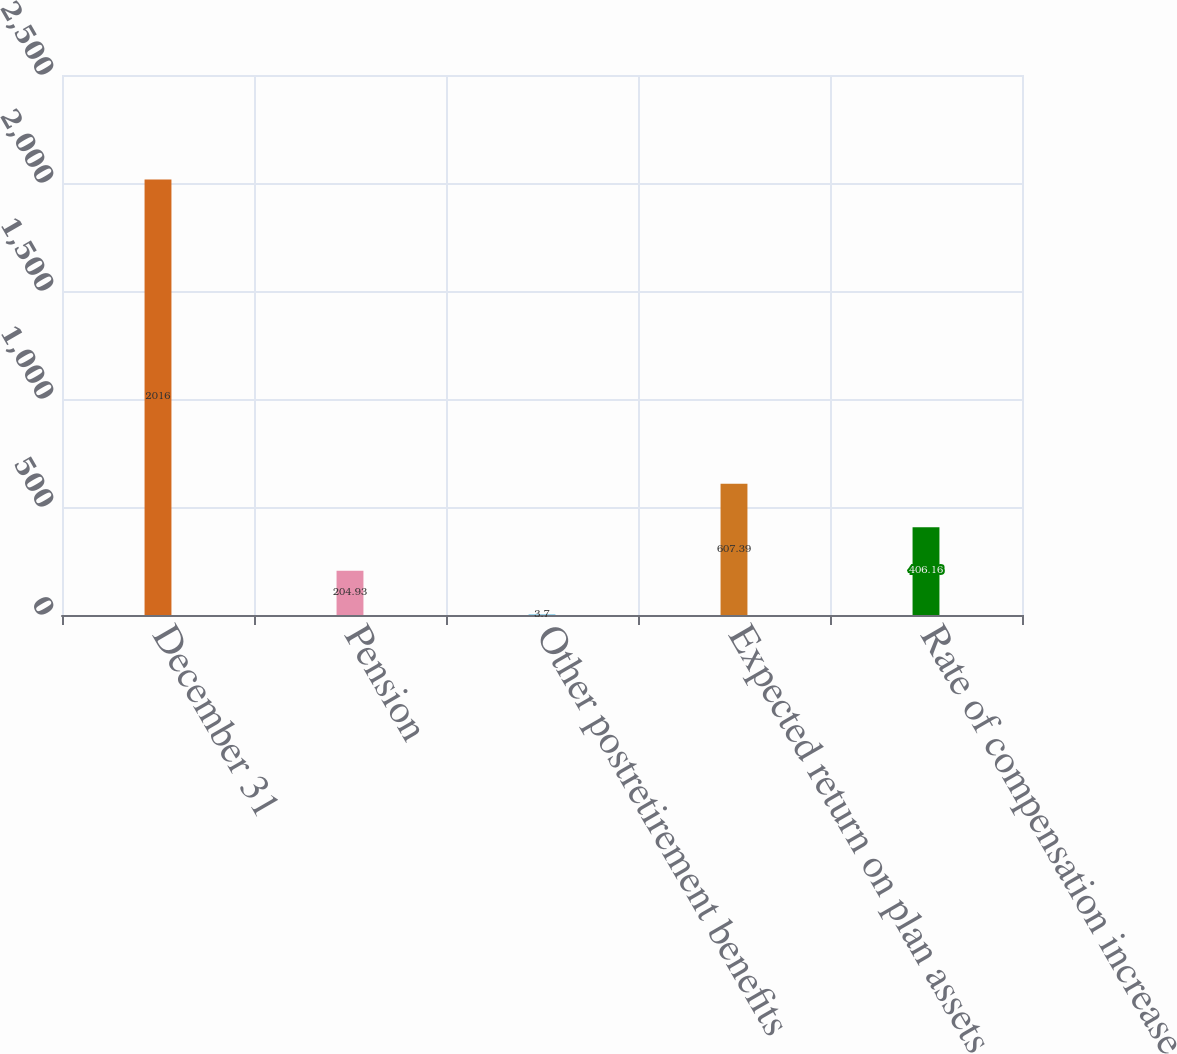Convert chart. <chart><loc_0><loc_0><loc_500><loc_500><bar_chart><fcel>December 31<fcel>Pension<fcel>Other postretirement benefits<fcel>Expected return on plan assets<fcel>Rate of compensation increase<nl><fcel>2016<fcel>204.93<fcel>3.7<fcel>607.39<fcel>406.16<nl></chart> 